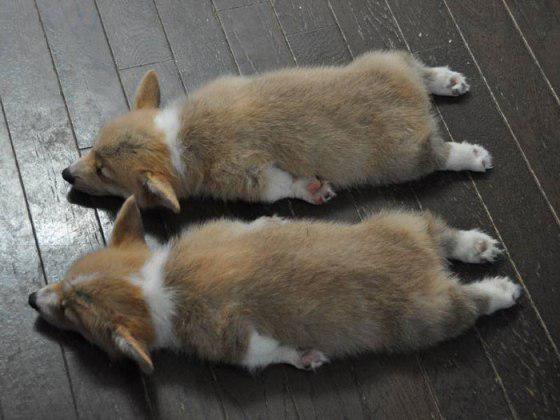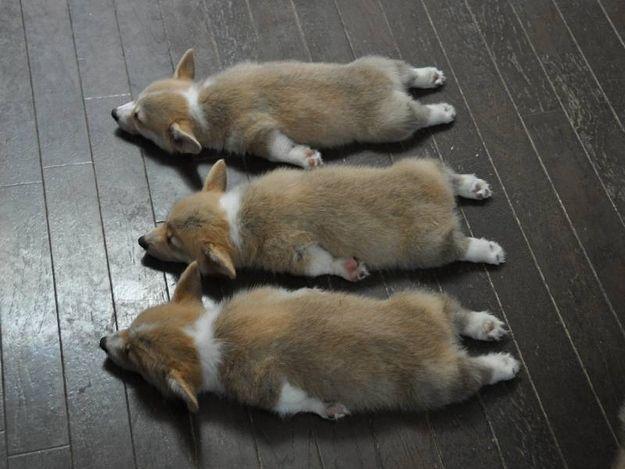The first image is the image on the left, the second image is the image on the right. Given the left and right images, does the statement "There are at least 5 dogs lying on the floor." hold true? Answer yes or no. Yes. The first image is the image on the left, the second image is the image on the right. For the images displayed, is the sentence "All of the dogs are lying down, either on their bellies or on their backs, but not on their side." factually correct? Answer yes or no. Yes. 